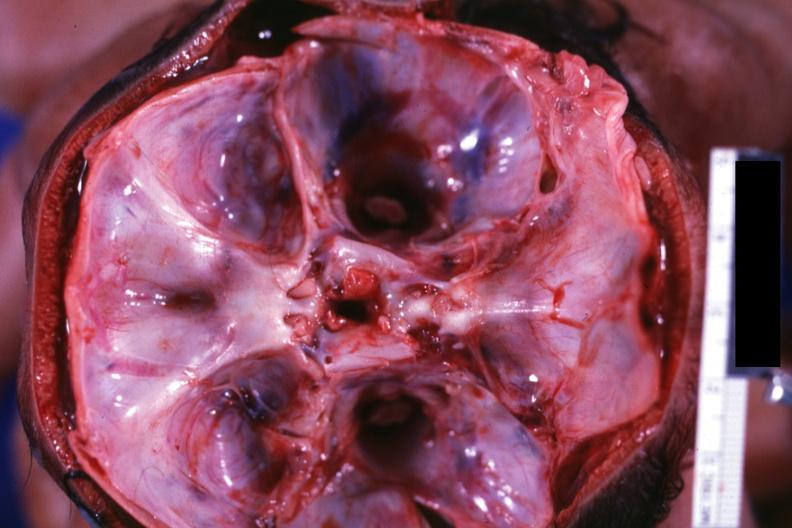what is present?
Answer the question using a single word or phrase. Bone 